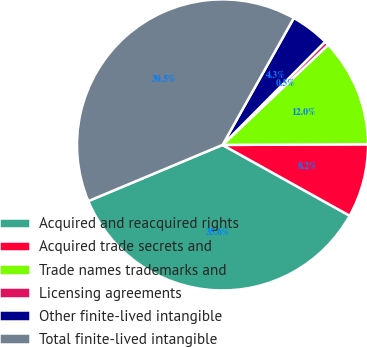<chart> <loc_0><loc_0><loc_500><loc_500><pie_chart><fcel>Acquired and reacquired rights<fcel>Acquired trade secrets and<fcel>Trade names trademarks and<fcel>Licensing agreements<fcel>Other finite-lived intangible<fcel>Total finite-lived intangible<nl><fcel>35.6%<fcel>8.16%<fcel>12.0%<fcel>0.47%<fcel>4.31%<fcel>39.45%<nl></chart> 